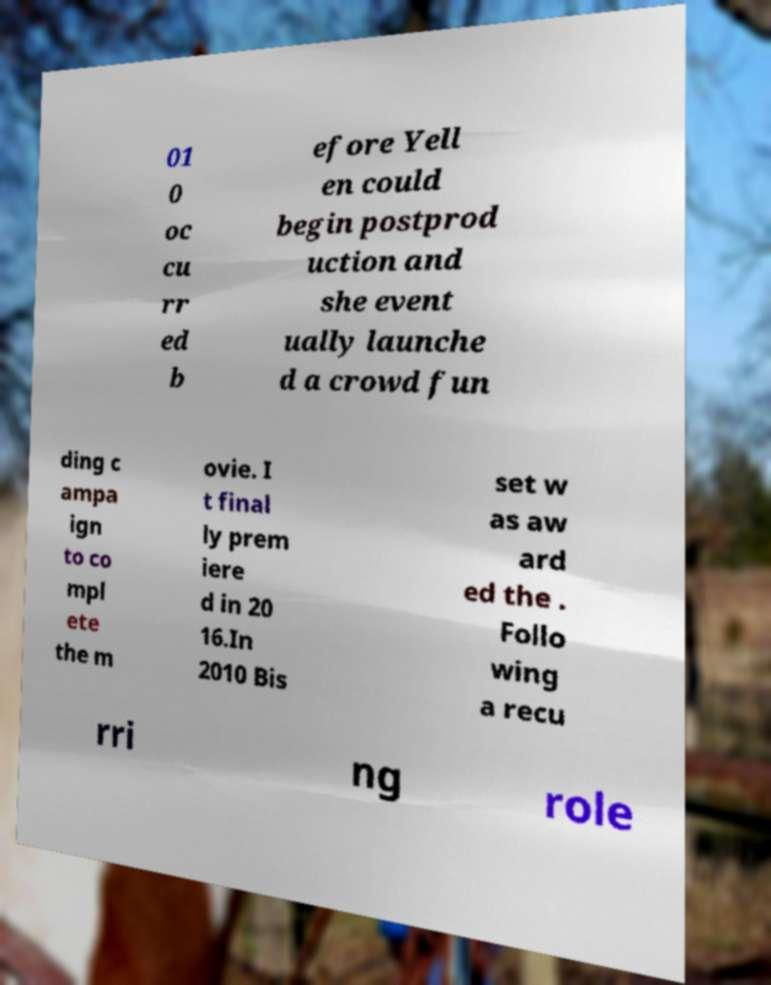There's text embedded in this image that I need extracted. Can you transcribe it verbatim? 01 0 oc cu rr ed b efore Yell en could begin postprod uction and she event ually launche d a crowd fun ding c ampa ign to co mpl ete the m ovie. I t final ly prem iere d in 20 16.In 2010 Bis set w as aw ard ed the . Follo wing a recu rri ng role 